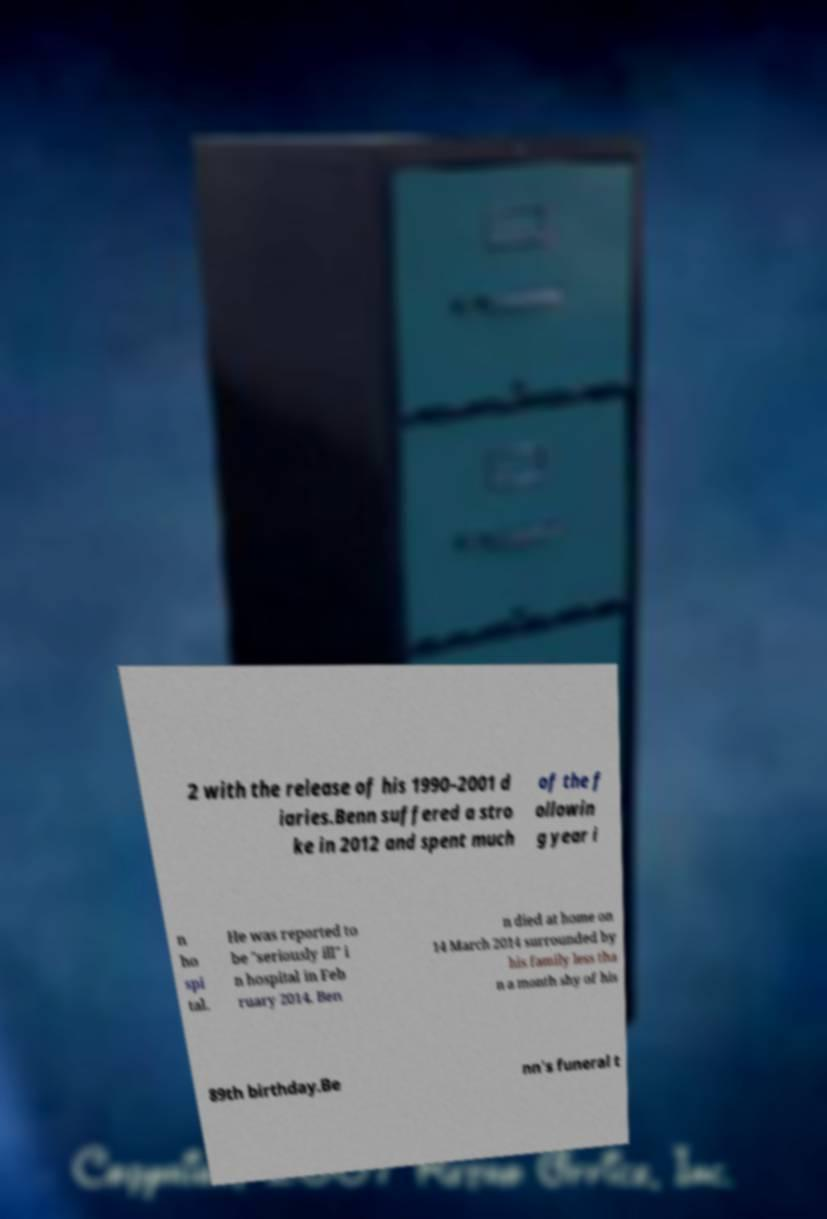I need the written content from this picture converted into text. Can you do that? 2 with the release of his 1990–2001 d iaries.Benn suffered a stro ke in 2012 and spent much of the f ollowin g year i n ho spi tal. He was reported to be "seriously ill" i n hospital in Feb ruary 2014. Ben n died at home on 14 March 2014 surrounded by his family less tha n a month shy of his 89th birthday.Be nn's funeral t 